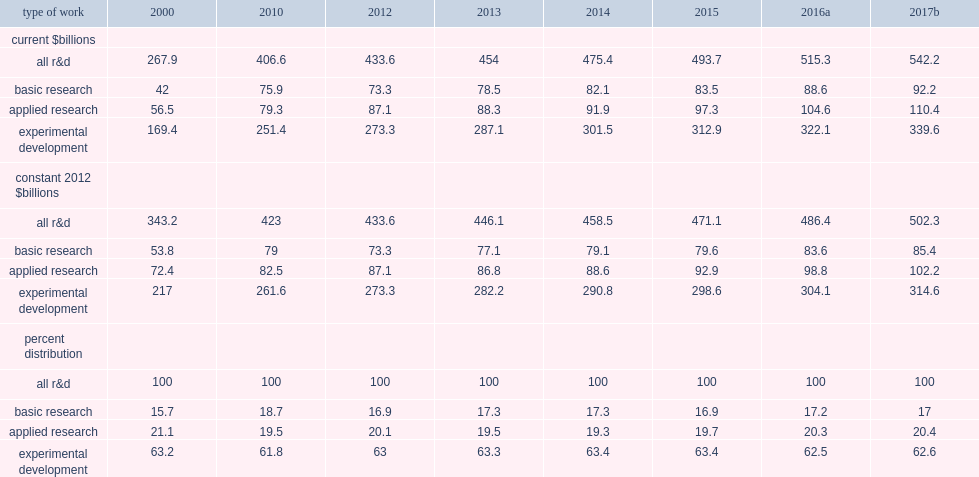How many billion dollars did basic research activities account for in 2016? 88.6. How many percentage points of total u.s. r&d expenditures did basic research activities account for? 0.171939. How many billion dollars did applied research activities account for in 2016? 104.6. How many percentage points of total u.s. r&d expenditures did applied research activities account for? 0.202989. How many billion dollars did experimental development activities account for in 2016? 322.1. How many percentage points of total u.s. r&d expenditures did experimental development activities account for? 0.625073. 